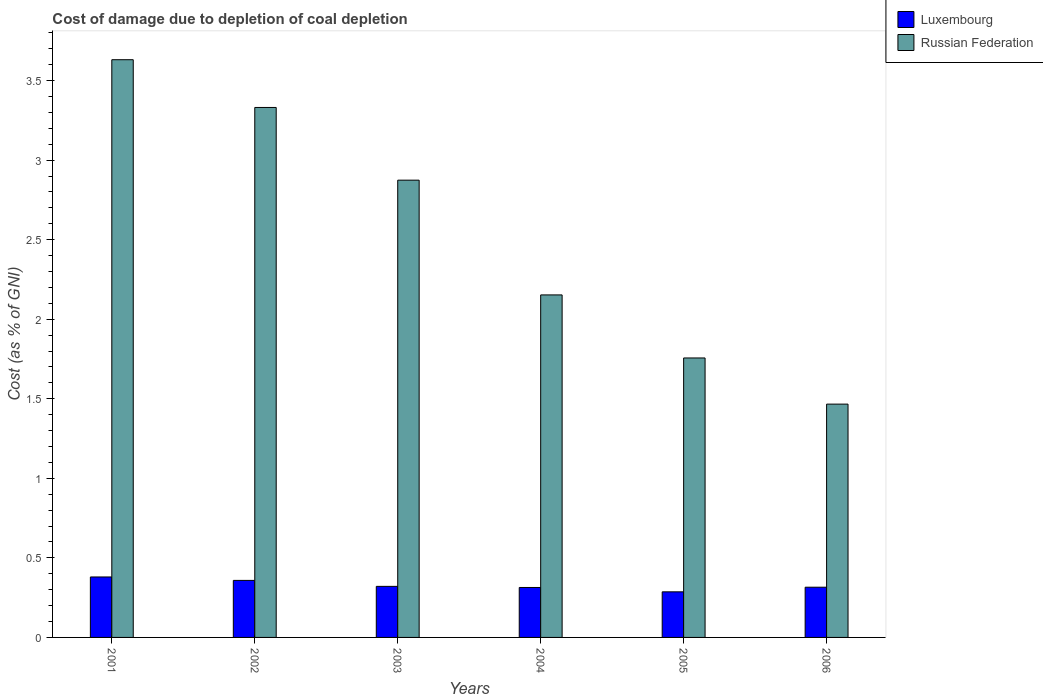Are the number of bars on each tick of the X-axis equal?
Offer a very short reply. Yes. How many bars are there on the 4th tick from the left?
Make the answer very short. 2. What is the label of the 2nd group of bars from the left?
Give a very brief answer. 2002. What is the cost of damage caused due to coal depletion in Luxembourg in 2001?
Your response must be concise. 0.38. Across all years, what is the maximum cost of damage caused due to coal depletion in Russian Federation?
Offer a very short reply. 3.63. Across all years, what is the minimum cost of damage caused due to coal depletion in Luxembourg?
Ensure brevity in your answer.  0.29. In which year was the cost of damage caused due to coal depletion in Russian Federation maximum?
Keep it short and to the point. 2001. In which year was the cost of damage caused due to coal depletion in Russian Federation minimum?
Your answer should be compact. 2006. What is the total cost of damage caused due to coal depletion in Luxembourg in the graph?
Your answer should be very brief. 1.98. What is the difference between the cost of damage caused due to coal depletion in Luxembourg in 2001 and that in 2005?
Make the answer very short. 0.09. What is the difference between the cost of damage caused due to coal depletion in Luxembourg in 2006 and the cost of damage caused due to coal depletion in Russian Federation in 2004?
Offer a terse response. -1.84. What is the average cost of damage caused due to coal depletion in Luxembourg per year?
Offer a very short reply. 0.33. In the year 2006, what is the difference between the cost of damage caused due to coal depletion in Russian Federation and cost of damage caused due to coal depletion in Luxembourg?
Offer a terse response. 1.15. What is the ratio of the cost of damage caused due to coal depletion in Russian Federation in 2001 to that in 2006?
Keep it short and to the point. 2.48. Is the cost of damage caused due to coal depletion in Russian Federation in 2003 less than that in 2006?
Keep it short and to the point. No. Is the difference between the cost of damage caused due to coal depletion in Russian Federation in 2003 and 2005 greater than the difference between the cost of damage caused due to coal depletion in Luxembourg in 2003 and 2005?
Give a very brief answer. Yes. What is the difference between the highest and the second highest cost of damage caused due to coal depletion in Luxembourg?
Your answer should be very brief. 0.02. What is the difference between the highest and the lowest cost of damage caused due to coal depletion in Luxembourg?
Offer a terse response. 0.09. What does the 2nd bar from the left in 2002 represents?
Provide a short and direct response. Russian Federation. What does the 1st bar from the right in 2003 represents?
Offer a very short reply. Russian Federation. Are all the bars in the graph horizontal?
Make the answer very short. No. How many years are there in the graph?
Make the answer very short. 6. What is the difference between two consecutive major ticks on the Y-axis?
Offer a very short reply. 0.5. Are the values on the major ticks of Y-axis written in scientific E-notation?
Make the answer very short. No. How many legend labels are there?
Provide a short and direct response. 2. How are the legend labels stacked?
Ensure brevity in your answer.  Vertical. What is the title of the graph?
Keep it short and to the point. Cost of damage due to depletion of coal depletion. Does "Barbados" appear as one of the legend labels in the graph?
Ensure brevity in your answer.  No. What is the label or title of the X-axis?
Offer a very short reply. Years. What is the label or title of the Y-axis?
Your answer should be compact. Cost (as % of GNI). What is the Cost (as % of GNI) in Luxembourg in 2001?
Ensure brevity in your answer.  0.38. What is the Cost (as % of GNI) in Russian Federation in 2001?
Offer a terse response. 3.63. What is the Cost (as % of GNI) in Luxembourg in 2002?
Keep it short and to the point. 0.36. What is the Cost (as % of GNI) of Russian Federation in 2002?
Offer a very short reply. 3.33. What is the Cost (as % of GNI) of Luxembourg in 2003?
Your answer should be compact. 0.32. What is the Cost (as % of GNI) of Russian Federation in 2003?
Your response must be concise. 2.87. What is the Cost (as % of GNI) in Luxembourg in 2004?
Give a very brief answer. 0.31. What is the Cost (as % of GNI) of Russian Federation in 2004?
Provide a short and direct response. 2.15. What is the Cost (as % of GNI) in Luxembourg in 2005?
Offer a terse response. 0.29. What is the Cost (as % of GNI) in Russian Federation in 2005?
Provide a short and direct response. 1.76. What is the Cost (as % of GNI) in Luxembourg in 2006?
Your response must be concise. 0.32. What is the Cost (as % of GNI) in Russian Federation in 2006?
Ensure brevity in your answer.  1.47. Across all years, what is the maximum Cost (as % of GNI) of Luxembourg?
Your response must be concise. 0.38. Across all years, what is the maximum Cost (as % of GNI) of Russian Federation?
Ensure brevity in your answer.  3.63. Across all years, what is the minimum Cost (as % of GNI) of Luxembourg?
Provide a succinct answer. 0.29. Across all years, what is the minimum Cost (as % of GNI) in Russian Federation?
Offer a terse response. 1.47. What is the total Cost (as % of GNI) of Luxembourg in the graph?
Your response must be concise. 1.98. What is the total Cost (as % of GNI) in Russian Federation in the graph?
Provide a short and direct response. 15.21. What is the difference between the Cost (as % of GNI) of Luxembourg in 2001 and that in 2002?
Your response must be concise. 0.02. What is the difference between the Cost (as % of GNI) of Russian Federation in 2001 and that in 2002?
Offer a very short reply. 0.3. What is the difference between the Cost (as % of GNI) of Luxembourg in 2001 and that in 2003?
Offer a very short reply. 0.06. What is the difference between the Cost (as % of GNI) of Russian Federation in 2001 and that in 2003?
Offer a very short reply. 0.76. What is the difference between the Cost (as % of GNI) in Luxembourg in 2001 and that in 2004?
Offer a very short reply. 0.07. What is the difference between the Cost (as % of GNI) in Russian Federation in 2001 and that in 2004?
Provide a succinct answer. 1.48. What is the difference between the Cost (as % of GNI) of Luxembourg in 2001 and that in 2005?
Make the answer very short. 0.09. What is the difference between the Cost (as % of GNI) in Russian Federation in 2001 and that in 2005?
Give a very brief answer. 1.87. What is the difference between the Cost (as % of GNI) in Luxembourg in 2001 and that in 2006?
Offer a terse response. 0.06. What is the difference between the Cost (as % of GNI) of Russian Federation in 2001 and that in 2006?
Keep it short and to the point. 2.17. What is the difference between the Cost (as % of GNI) of Luxembourg in 2002 and that in 2003?
Your response must be concise. 0.04. What is the difference between the Cost (as % of GNI) in Russian Federation in 2002 and that in 2003?
Keep it short and to the point. 0.46. What is the difference between the Cost (as % of GNI) in Luxembourg in 2002 and that in 2004?
Give a very brief answer. 0.04. What is the difference between the Cost (as % of GNI) in Russian Federation in 2002 and that in 2004?
Your answer should be very brief. 1.18. What is the difference between the Cost (as % of GNI) in Luxembourg in 2002 and that in 2005?
Provide a short and direct response. 0.07. What is the difference between the Cost (as % of GNI) of Russian Federation in 2002 and that in 2005?
Your answer should be very brief. 1.57. What is the difference between the Cost (as % of GNI) in Luxembourg in 2002 and that in 2006?
Provide a succinct answer. 0.04. What is the difference between the Cost (as % of GNI) in Russian Federation in 2002 and that in 2006?
Provide a short and direct response. 1.86. What is the difference between the Cost (as % of GNI) of Luxembourg in 2003 and that in 2004?
Offer a terse response. 0.01. What is the difference between the Cost (as % of GNI) of Russian Federation in 2003 and that in 2004?
Ensure brevity in your answer.  0.72. What is the difference between the Cost (as % of GNI) in Luxembourg in 2003 and that in 2005?
Provide a succinct answer. 0.03. What is the difference between the Cost (as % of GNI) of Russian Federation in 2003 and that in 2005?
Make the answer very short. 1.12. What is the difference between the Cost (as % of GNI) of Luxembourg in 2003 and that in 2006?
Your response must be concise. 0.01. What is the difference between the Cost (as % of GNI) of Russian Federation in 2003 and that in 2006?
Offer a terse response. 1.41. What is the difference between the Cost (as % of GNI) in Luxembourg in 2004 and that in 2005?
Your answer should be very brief. 0.03. What is the difference between the Cost (as % of GNI) in Russian Federation in 2004 and that in 2005?
Provide a succinct answer. 0.4. What is the difference between the Cost (as % of GNI) in Luxembourg in 2004 and that in 2006?
Your response must be concise. -0. What is the difference between the Cost (as % of GNI) in Russian Federation in 2004 and that in 2006?
Make the answer very short. 0.69. What is the difference between the Cost (as % of GNI) of Luxembourg in 2005 and that in 2006?
Make the answer very short. -0.03. What is the difference between the Cost (as % of GNI) of Russian Federation in 2005 and that in 2006?
Keep it short and to the point. 0.29. What is the difference between the Cost (as % of GNI) in Luxembourg in 2001 and the Cost (as % of GNI) in Russian Federation in 2002?
Ensure brevity in your answer.  -2.95. What is the difference between the Cost (as % of GNI) in Luxembourg in 2001 and the Cost (as % of GNI) in Russian Federation in 2003?
Give a very brief answer. -2.49. What is the difference between the Cost (as % of GNI) of Luxembourg in 2001 and the Cost (as % of GNI) of Russian Federation in 2004?
Your answer should be very brief. -1.77. What is the difference between the Cost (as % of GNI) in Luxembourg in 2001 and the Cost (as % of GNI) in Russian Federation in 2005?
Provide a short and direct response. -1.38. What is the difference between the Cost (as % of GNI) of Luxembourg in 2001 and the Cost (as % of GNI) of Russian Federation in 2006?
Make the answer very short. -1.09. What is the difference between the Cost (as % of GNI) in Luxembourg in 2002 and the Cost (as % of GNI) in Russian Federation in 2003?
Your response must be concise. -2.52. What is the difference between the Cost (as % of GNI) in Luxembourg in 2002 and the Cost (as % of GNI) in Russian Federation in 2004?
Make the answer very short. -1.79. What is the difference between the Cost (as % of GNI) in Luxembourg in 2002 and the Cost (as % of GNI) in Russian Federation in 2005?
Your answer should be compact. -1.4. What is the difference between the Cost (as % of GNI) in Luxembourg in 2002 and the Cost (as % of GNI) in Russian Federation in 2006?
Ensure brevity in your answer.  -1.11. What is the difference between the Cost (as % of GNI) of Luxembourg in 2003 and the Cost (as % of GNI) of Russian Federation in 2004?
Your response must be concise. -1.83. What is the difference between the Cost (as % of GNI) in Luxembourg in 2003 and the Cost (as % of GNI) in Russian Federation in 2005?
Keep it short and to the point. -1.44. What is the difference between the Cost (as % of GNI) in Luxembourg in 2003 and the Cost (as % of GNI) in Russian Federation in 2006?
Your response must be concise. -1.15. What is the difference between the Cost (as % of GNI) in Luxembourg in 2004 and the Cost (as % of GNI) in Russian Federation in 2005?
Ensure brevity in your answer.  -1.44. What is the difference between the Cost (as % of GNI) of Luxembourg in 2004 and the Cost (as % of GNI) of Russian Federation in 2006?
Your response must be concise. -1.15. What is the difference between the Cost (as % of GNI) of Luxembourg in 2005 and the Cost (as % of GNI) of Russian Federation in 2006?
Your answer should be very brief. -1.18. What is the average Cost (as % of GNI) of Luxembourg per year?
Provide a short and direct response. 0.33. What is the average Cost (as % of GNI) in Russian Federation per year?
Ensure brevity in your answer.  2.54. In the year 2001, what is the difference between the Cost (as % of GNI) of Luxembourg and Cost (as % of GNI) of Russian Federation?
Your answer should be very brief. -3.25. In the year 2002, what is the difference between the Cost (as % of GNI) of Luxembourg and Cost (as % of GNI) of Russian Federation?
Provide a succinct answer. -2.97. In the year 2003, what is the difference between the Cost (as % of GNI) of Luxembourg and Cost (as % of GNI) of Russian Federation?
Ensure brevity in your answer.  -2.55. In the year 2004, what is the difference between the Cost (as % of GNI) in Luxembourg and Cost (as % of GNI) in Russian Federation?
Provide a short and direct response. -1.84. In the year 2005, what is the difference between the Cost (as % of GNI) in Luxembourg and Cost (as % of GNI) in Russian Federation?
Your answer should be compact. -1.47. In the year 2006, what is the difference between the Cost (as % of GNI) of Luxembourg and Cost (as % of GNI) of Russian Federation?
Your answer should be compact. -1.15. What is the ratio of the Cost (as % of GNI) of Luxembourg in 2001 to that in 2002?
Your answer should be compact. 1.06. What is the ratio of the Cost (as % of GNI) in Russian Federation in 2001 to that in 2002?
Your answer should be very brief. 1.09. What is the ratio of the Cost (as % of GNI) in Luxembourg in 2001 to that in 2003?
Give a very brief answer. 1.18. What is the ratio of the Cost (as % of GNI) in Russian Federation in 2001 to that in 2003?
Keep it short and to the point. 1.26. What is the ratio of the Cost (as % of GNI) in Luxembourg in 2001 to that in 2004?
Keep it short and to the point. 1.21. What is the ratio of the Cost (as % of GNI) of Russian Federation in 2001 to that in 2004?
Give a very brief answer. 1.69. What is the ratio of the Cost (as % of GNI) of Luxembourg in 2001 to that in 2005?
Offer a very short reply. 1.33. What is the ratio of the Cost (as % of GNI) of Russian Federation in 2001 to that in 2005?
Give a very brief answer. 2.07. What is the ratio of the Cost (as % of GNI) of Luxembourg in 2001 to that in 2006?
Your answer should be compact. 1.2. What is the ratio of the Cost (as % of GNI) of Russian Federation in 2001 to that in 2006?
Ensure brevity in your answer.  2.48. What is the ratio of the Cost (as % of GNI) in Luxembourg in 2002 to that in 2003?
Offer a terse response. 1.12. What is the ratio of the Cost (as % of GNI) of Russian Federation in 2002 to that in 2003?
Make the answer very short. 1.16. What is the ratio of the Cost (as % of GNI) of Luxembourg in 2002 to that in 2004?
Provide a short and direct response. 1.14. What is the ratio of the Cost (as % of GNI) of Russian Federation in 2002 to that in 2004?
Keep it short and to the point. 1.55. What is the ratio of the Cost (as % of GNI) in Luxembourg in 2002 to that in 2005?
Offer a terse response. 1.25. What is the ratio of the Cost (as % of GNI) in Russian Federation in 2002 to that in 2005?
Provide a succinct answer. 1.9. What is the ratio of the Cost (as % of GNI) in Luxembourg in 2002 to that in 2006?
Give a very brief answer. 1.14. What is the ratio of the Cost (as % of GNI) in Russian Federation in 2002 to that in 2006?
Give a very brief answer. 2.27. What is the ratio of the Cost (as % of GNI) of Luxembourg in 2003 to that in 2004?
Ensure brevity in your answer.  1.02. What is the ratio of the Cost (as % of GNI) of Russian Federation in 2003 to that in 2004?
Ensure brevity in your answer.  1.33. What is the ratio of the Cost (as % of GNI) of Luxembourg in 2003 to that in 2005?
Your answer should be compact. 1.12. What is the ratio of the Cost (as % of GNI) in Russian Federation in 2003 to that in 2005?
Your answer should be very brief. 1.64. What is the ratio of the Cost (as % of GNI) of Luxembourg in 2003 to that in 2006?
Your answer should be compact. 1.02. What is the ratio of the Cost (as % of GNI) of Russian Federation in 2003 to that in 2006?
Offer a terse response. 1.96. What is the ratio of the Cost (as % of GNI) in Luxembourg in 2004 to that in 2005?
Make the answer very short. 1.1. What is the ratio of the Cost (as % of GNI) of Russian Federation in 2004 to that in 2005?
Offer a terse response. 1.23. What is the ratio of the Cost (as % of GNI) of Luxembourg in 2004 to that in 2006?
Provide a short and direct response. 0.99. What is the ratio of the Cost (as % of GNI) of Russian Federation in 2004 to that in 2006?
Offer a terse response. 1.47. What is the ratio of the Cost (as % of GNI) in Luxembourg in 2005 to that in 2006?
Provide a succinct answer. 0.91. What is the ratio of the Cost (as % of GNI) in Russian Federation in 2005 to that in 2006?
Make the answer very short. 1.2. What is the difference between the highest and the second highest Cost (as % of GNI) of Luxembourg?
Ensure brevity in your answer.  0.02. What is the difference between the highest and the second highest Cost (as % of GNI) of Russian Federation?
Provide a succinct answer. 0.3. What is the difference between the highest and the lowest Cost (as % of GNI) of Luxembourg?
Give a very brief answer. 0.09. What is the difference between the highest and the lowest Cost (as % of GNI) of Russian Federation?
Ensure brevity in your answer.  2.17. 